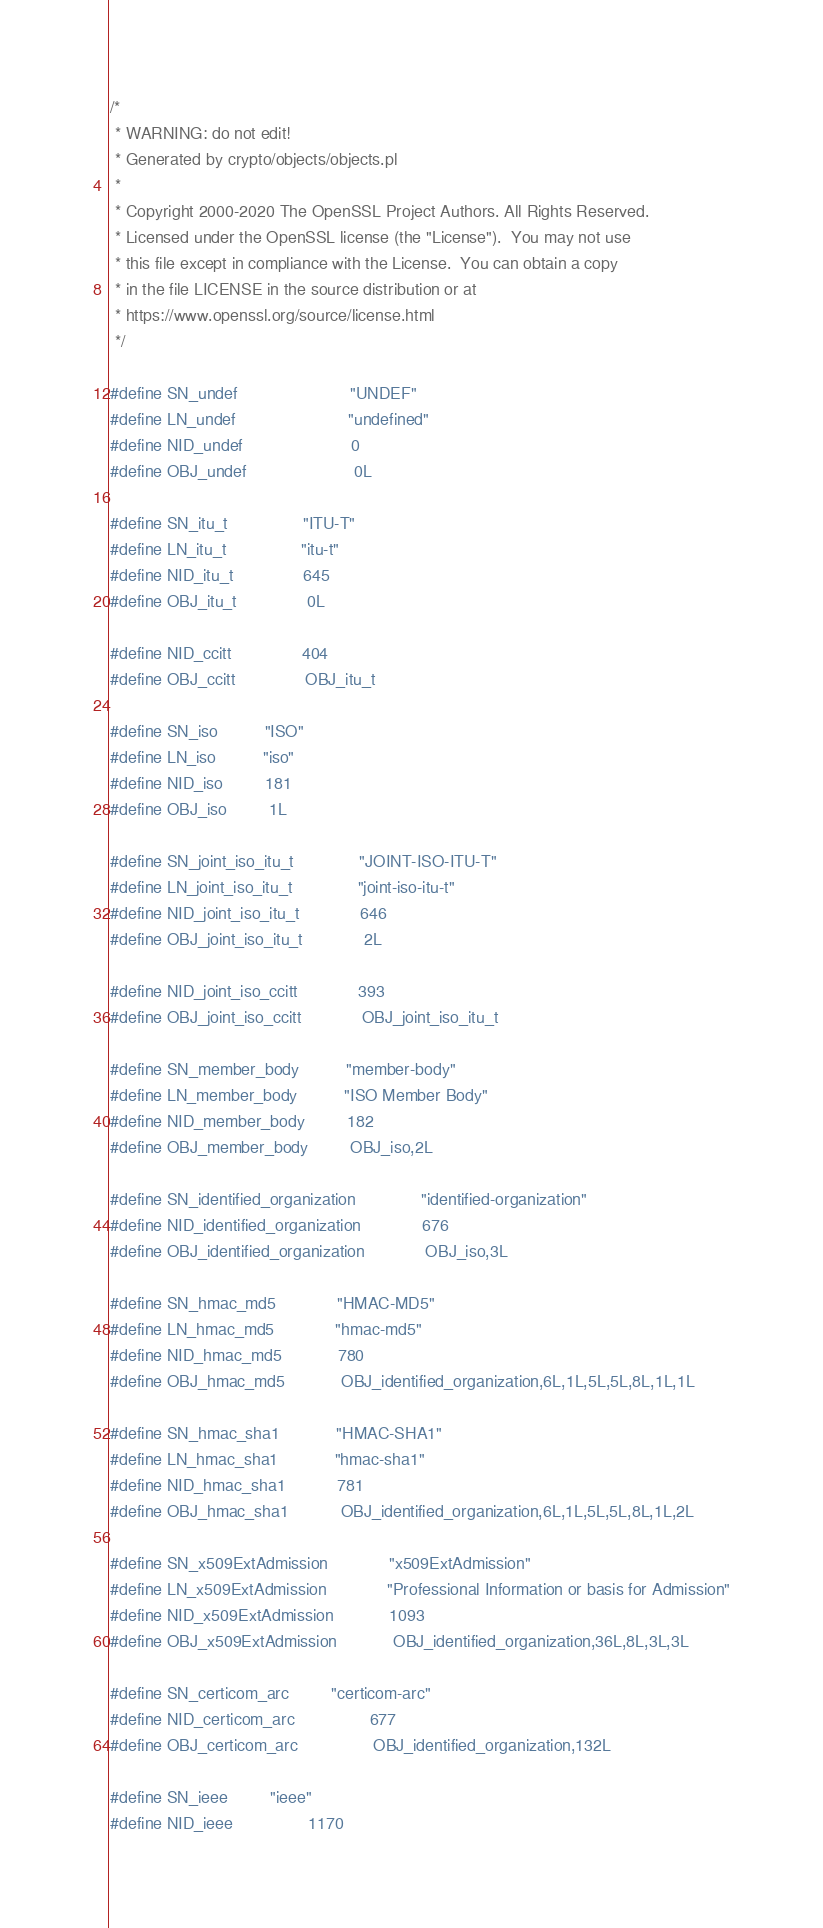Convert code to text. <code><loc_0><loc_0><loc_500><loc_500><_C_>/*
 * WARNING: do not edit!
 * Generated by crypto/objects/objects.pl
 *
 * Copyright 2000-2020 The OpenSSL Project Authors. All Rights Reserved.
 * Licensed under the OpenSSL license (the "License").  You may not use
 * this file except in compliance with the License.  You can obtain a copy
 * in the file LICENSE in the source distribution or at
 * https://www.openssl.org/source/license.html
 */

#define SN_undef                        "UNDEF"
#define LN_undef                        "undefined"
#define NID_undef                       0
#define OBJ_undef                       0L

#define SN_itu_t                "ITU-T"
#define LN_itu_t                "itu-t"
#define NID_itu_t               645
#define OBJ_itu_t               0L

#define NID_ccitt               404
#define OBJ_ccitt               OBJ_itu_t

#define SN_iso          "ISO"
#define LN_iso          "iso"
#define NID_iso         181
#define OBJ_iso         1L

#define SN_joint_iso_itu_t              "JOINT-ISO-ITU-T"
#define LN_joint_iso_itu_t              "joint-iso-itu-t"
#define NID_joint_iso_itu_t             646
#define OBJ_joint_iso_itu_t             2L

#define NID_joint_iso_ccitt             393
#define OBJ_joint_iso_ccitt             OBJ_joint_iso_itu_t

#define SN_member_body          "member-body"
#define LN_member_body          "ISO Member Body"
#define NID_member_body         182
#define OBJ_member_body         OBJ_iso,2L

#define SN_identified_organization              "identified-organization"
#define NID_identified_organization             676
#define OBJ_identified_organization             OBJ_iso,3L

#define SN_hmac_md5             "HMAC-MD5"
#define LN_hmac_md5             "hmac-md5"
#define NID_hmac_md5            780
#define OBJ_hmac_md5            OBJ_identified_organization,6L,1L,5L,5L,8L,1L,1L

#define SN_hmac_sha1            "HMAC-SHA1"
#define LN_hmac_sha1            "hmac-sha1"
#define NID_hmac_sha1           781
#define OBJ_hmac_sha1           OBJ_identified_organization,6L,1L,5L,5L,8L,1L,2L

#define SN_x509ExtAdmission             "x509ExtAdmission"
#define LN_x509ExtAdmission             "Professional Information or basis for Admission"
#define NID_x509ExtAdmission            1093
#define OBJ_x509ExtAdmission            OBJ_identified_organization,36L,8L,3L,3L

#define SN_certicom_arc         "certicom-arc"
#define NID_certicom_arc                677
#define OBJ_certicom_arc                OBJ_identified_organization,132L

#define SN_ieee         "ieee"
#define NID_ieee                1170</code> 